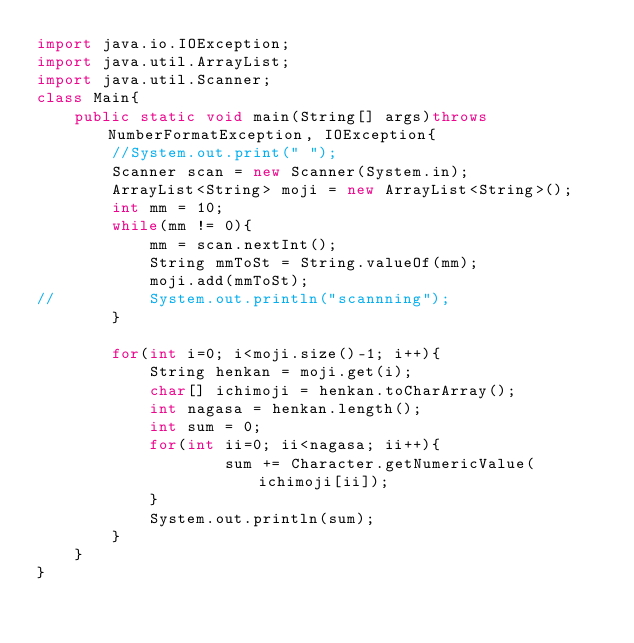Convert code to text. <code><loc_0><loc_0><loc_500><loc_500><_Java_>import java.io.IOException;
import java.util.ArrayList;
import java.util.Scanner;
class Main{
	public static void main(String[] args)throws NumberFormatException, IOException{
		//System.out.print(" ");
		Scanner scan = new Scanner(System.in);
		ArrayList<String> moji = new ArrayList<String>();
		int mm = 10;
		while(mm != 0){
			mm = scan.nextInt();
			String mmToSt = String.valueOf(mm);
			moji.add(mmToSt);
//			System.out.println("scannning");
		}
		
		for(int i=0; i<moji.size()-1; i++){
			String henkan = moji.get(i);
			char[] ichimoji = henkan.toCharArray();
			int nagasa = henkan.length();
			int sum = 0;
			for(int ii=0; ii<nagasa; ii++){
					sum += Character.getNumericValue(ichimoji[ii]);
			}
			System.out.println(sum);
		}
	}
}</code> 